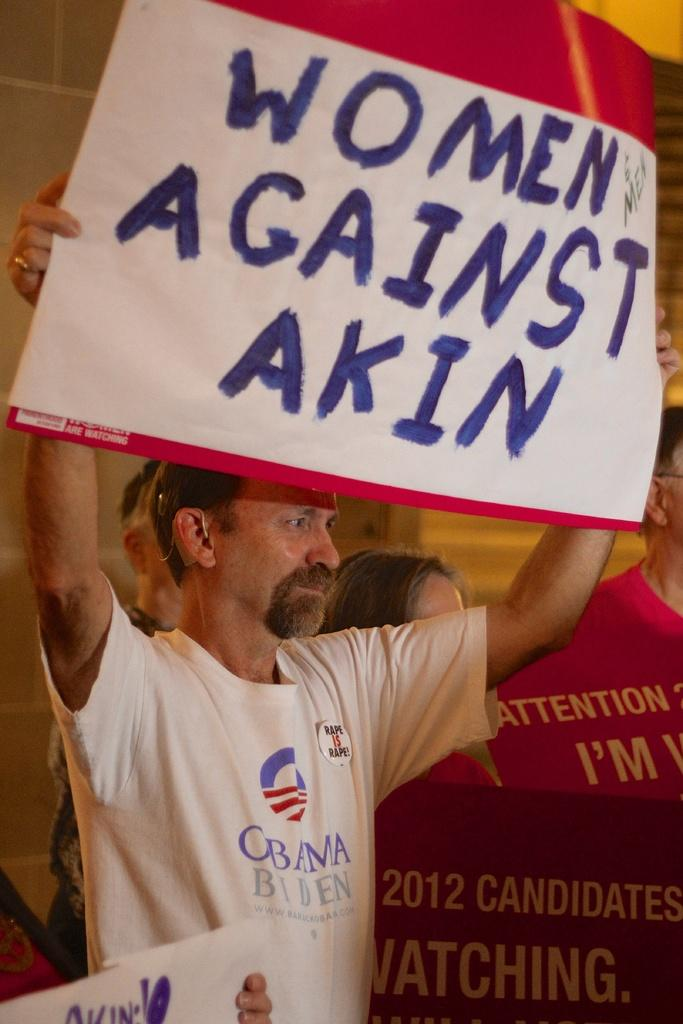<image>
Share a concise interpretation of the image provided. A man is at a demo and holds a sign saying Women Against Akin 